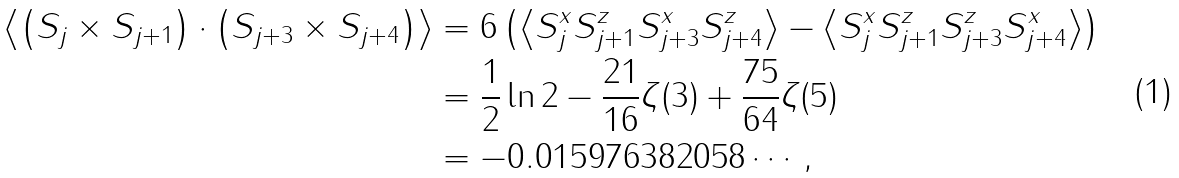Convert formula to latex. <formula><loc_0><loc_0><loc_500><loc_500>\left \langle \left ( { S } _ { j } \times { S } _ { j + 1 } \right ) \cdot \left ( { S } _ { j + 3 } \times { S } _ { j + 4 } \right ) \right \rangle & = 6 \left ( \left \langle S _ { j } ^ { x } S _ { j + 1 } ^ { z } S _ { j + 3 } ^ { x } S _ { j + 4 } ^ { z } \right \rangle - \left \langle S _ { j } ^ { x } S _ { j + 1 } ^ { z } S _ { j + 3 } ^ { z } S _ { j + 4 } ^ { x } \right \rangle \right ) \\ & = \frac { 1 } { 2 } \ln 2 - \frac { 2 1 } { 1 6 } \zeta ( 3 ) + \frac { 7 5 } { 6 4 } \zeta ( 5 ) \\ & = - 0 . 0 1 5 9 7 6 3 8 2 0 5 8 \cdots ,</formula> 